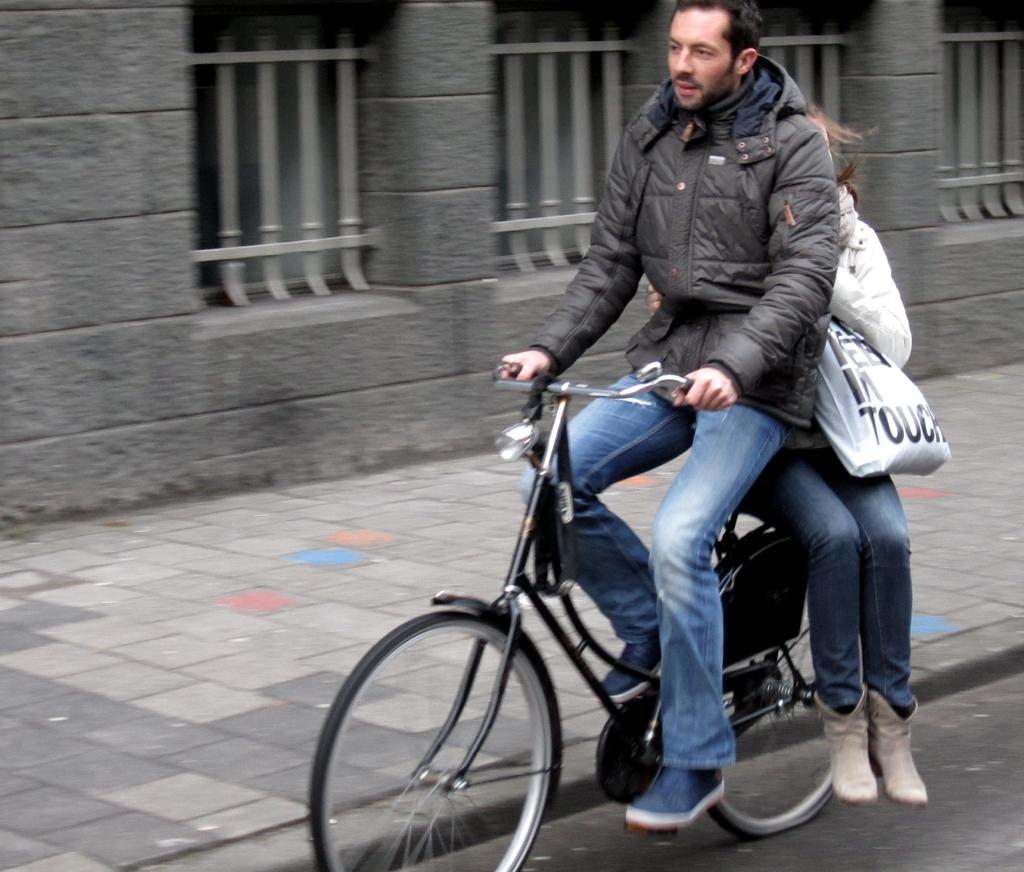How many people are in the image? There are two people in the image, a man and a woman. What are the man and woman doing in the image? They are sitting on a bicycle and riding on a road. What can be seen beside them in the image? There is a wall beside them. What type of alley can be seen in the image? There is no alley present in the image; it features a man and a woman sitting on a bicycle and riding on a road. 